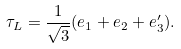<formula> <loc_0><loc_0><loc_500><loc_500>\tau _ { L } = \frac { 1 } { \sqrt { 3 } } ( e _ { 1 } + e _ { 2 } + e ^ { \prime } _ { 3 } ) .</formula> 